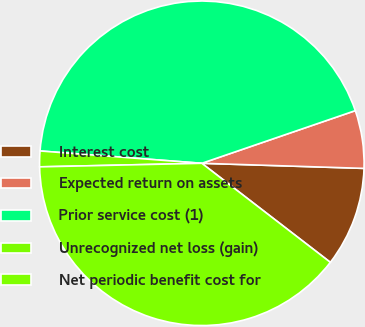Convert chart to OTSL. <chart><loc_0><loc_0><loc_500><loc_500><pie_chart><fcel>Interest cost<fcel>Expected return on assets<fcel>Prior service cost (1)<fcel>Unrecognized net loss (gain)<fcel>Net periodic benefit cost for<nl><fcel>9.95%<fcel>5.76%<fcel>43.53%<fcel>1.56%<fcel>39.2%<nl></chart> 